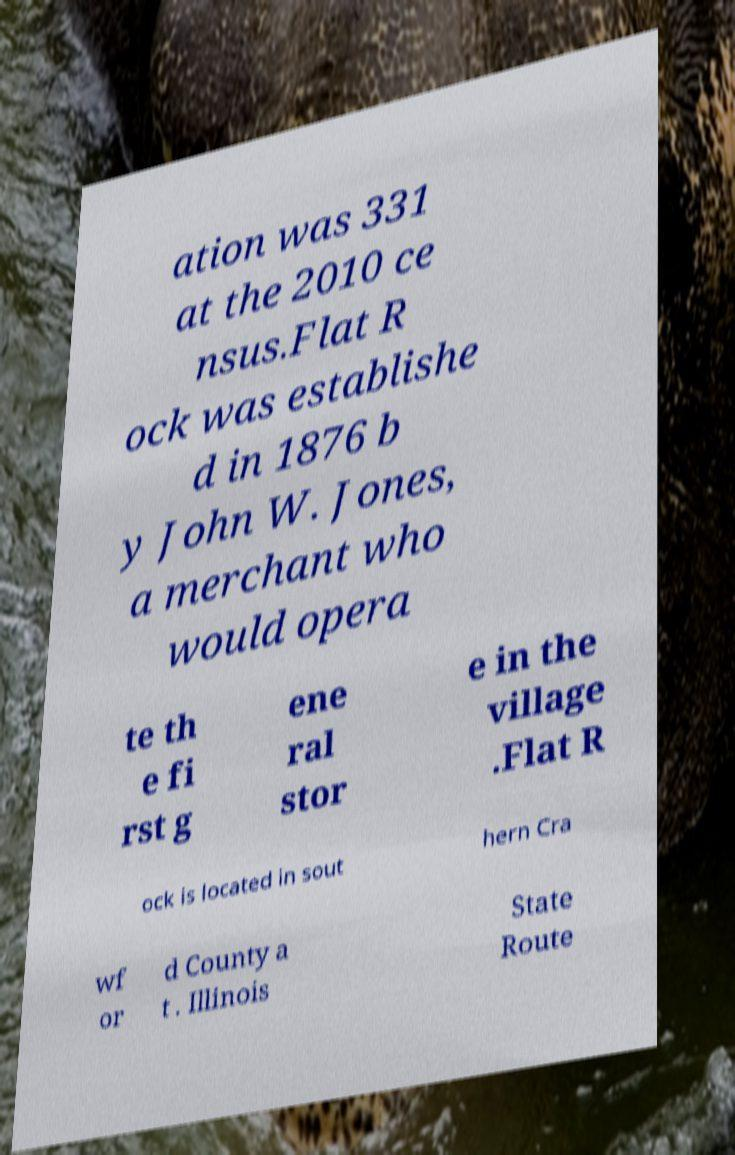I need the written content from this picture converted into text. Can you do that? ation was 331 at the 2010 ce nsus.Flat R ock was establishe d in 1876 b y John W. Jones, a merchant who would opera te th e fi rst g ene ral stor e in the village .Flat R ock is located in sout hern Cra wf or d County a t . Illinois State Route 